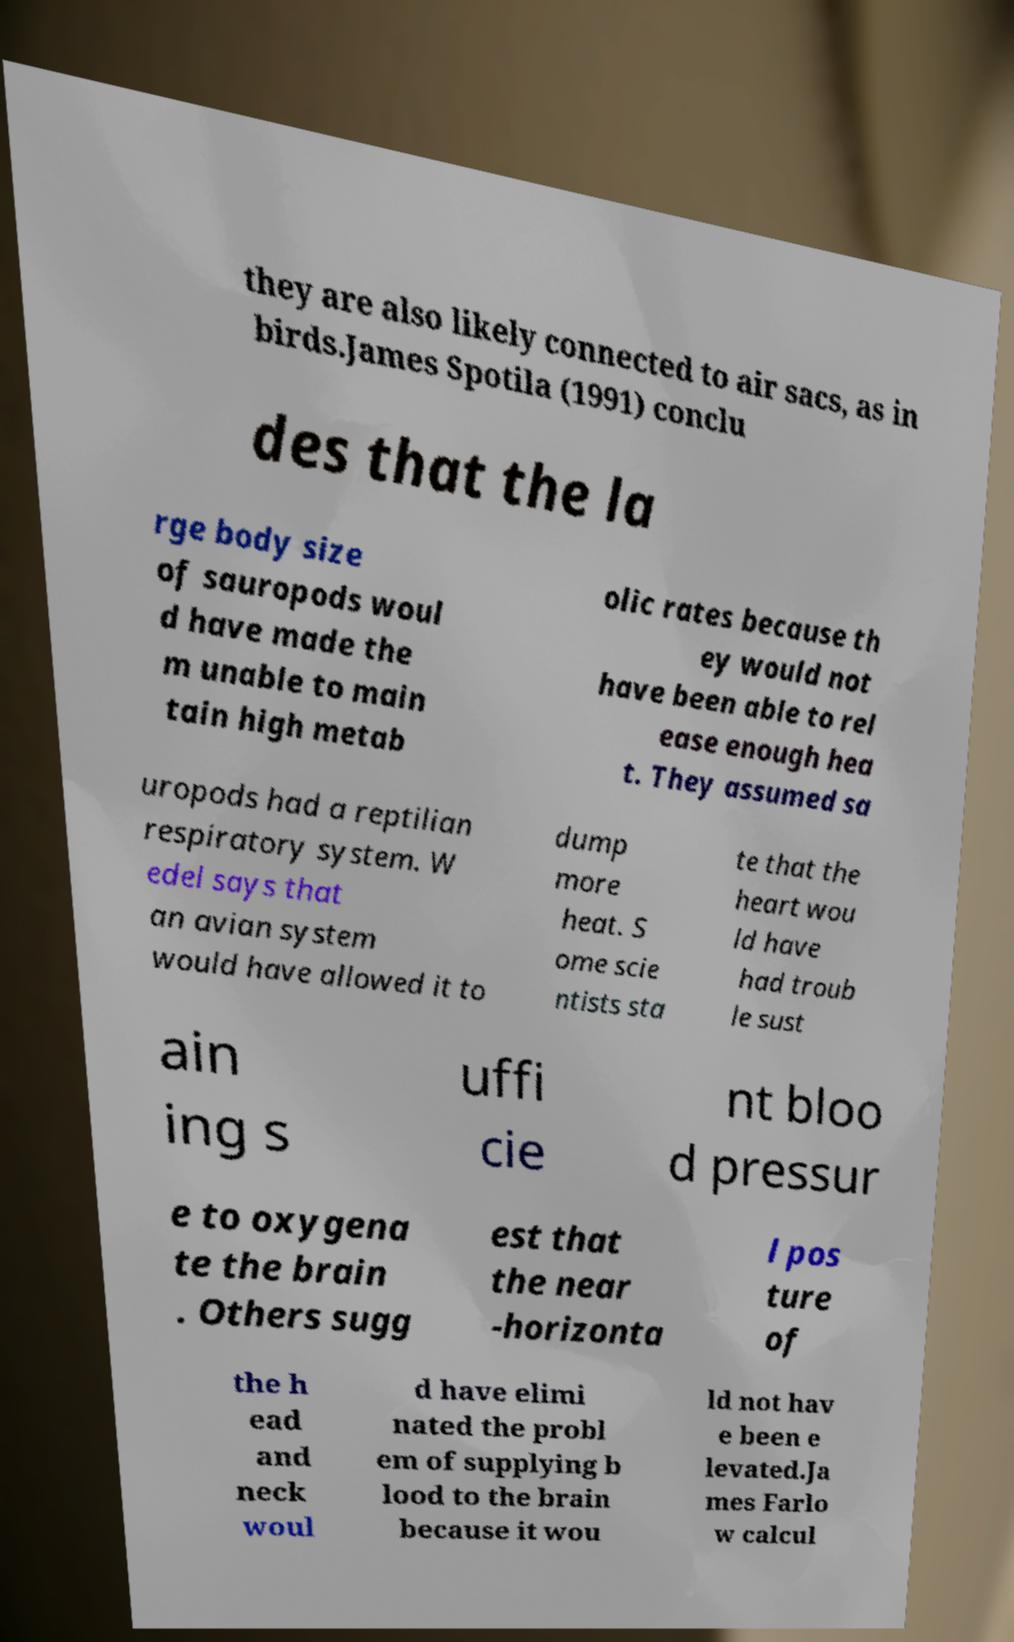Please identify and transcribe the text found in this image. they are also likely connected to air sacs, as in birds.James Spotila (1991) conclu des that the la rge body size of sauropods woul d have made the m unable to main tain high metab olic rates because th ey would not have been able to rel ease enough hea t. They assumed sa uropods had a reptilian respiratory system. W edel says that an avian system would have allowed it to dump more heat. S ome scie ntists sta te that the heart wou ld have had troub le sust ain ing s uffi cie nt bloo d pressur e to oxygena te the brain . Others sugg est that the near -horizonta l pos ture of the h ead and neck woul d have elimi nated the probl em of supplying b lood to the brain because it wou ld not hav e been e levated.Ja mes Farlo w calcul 